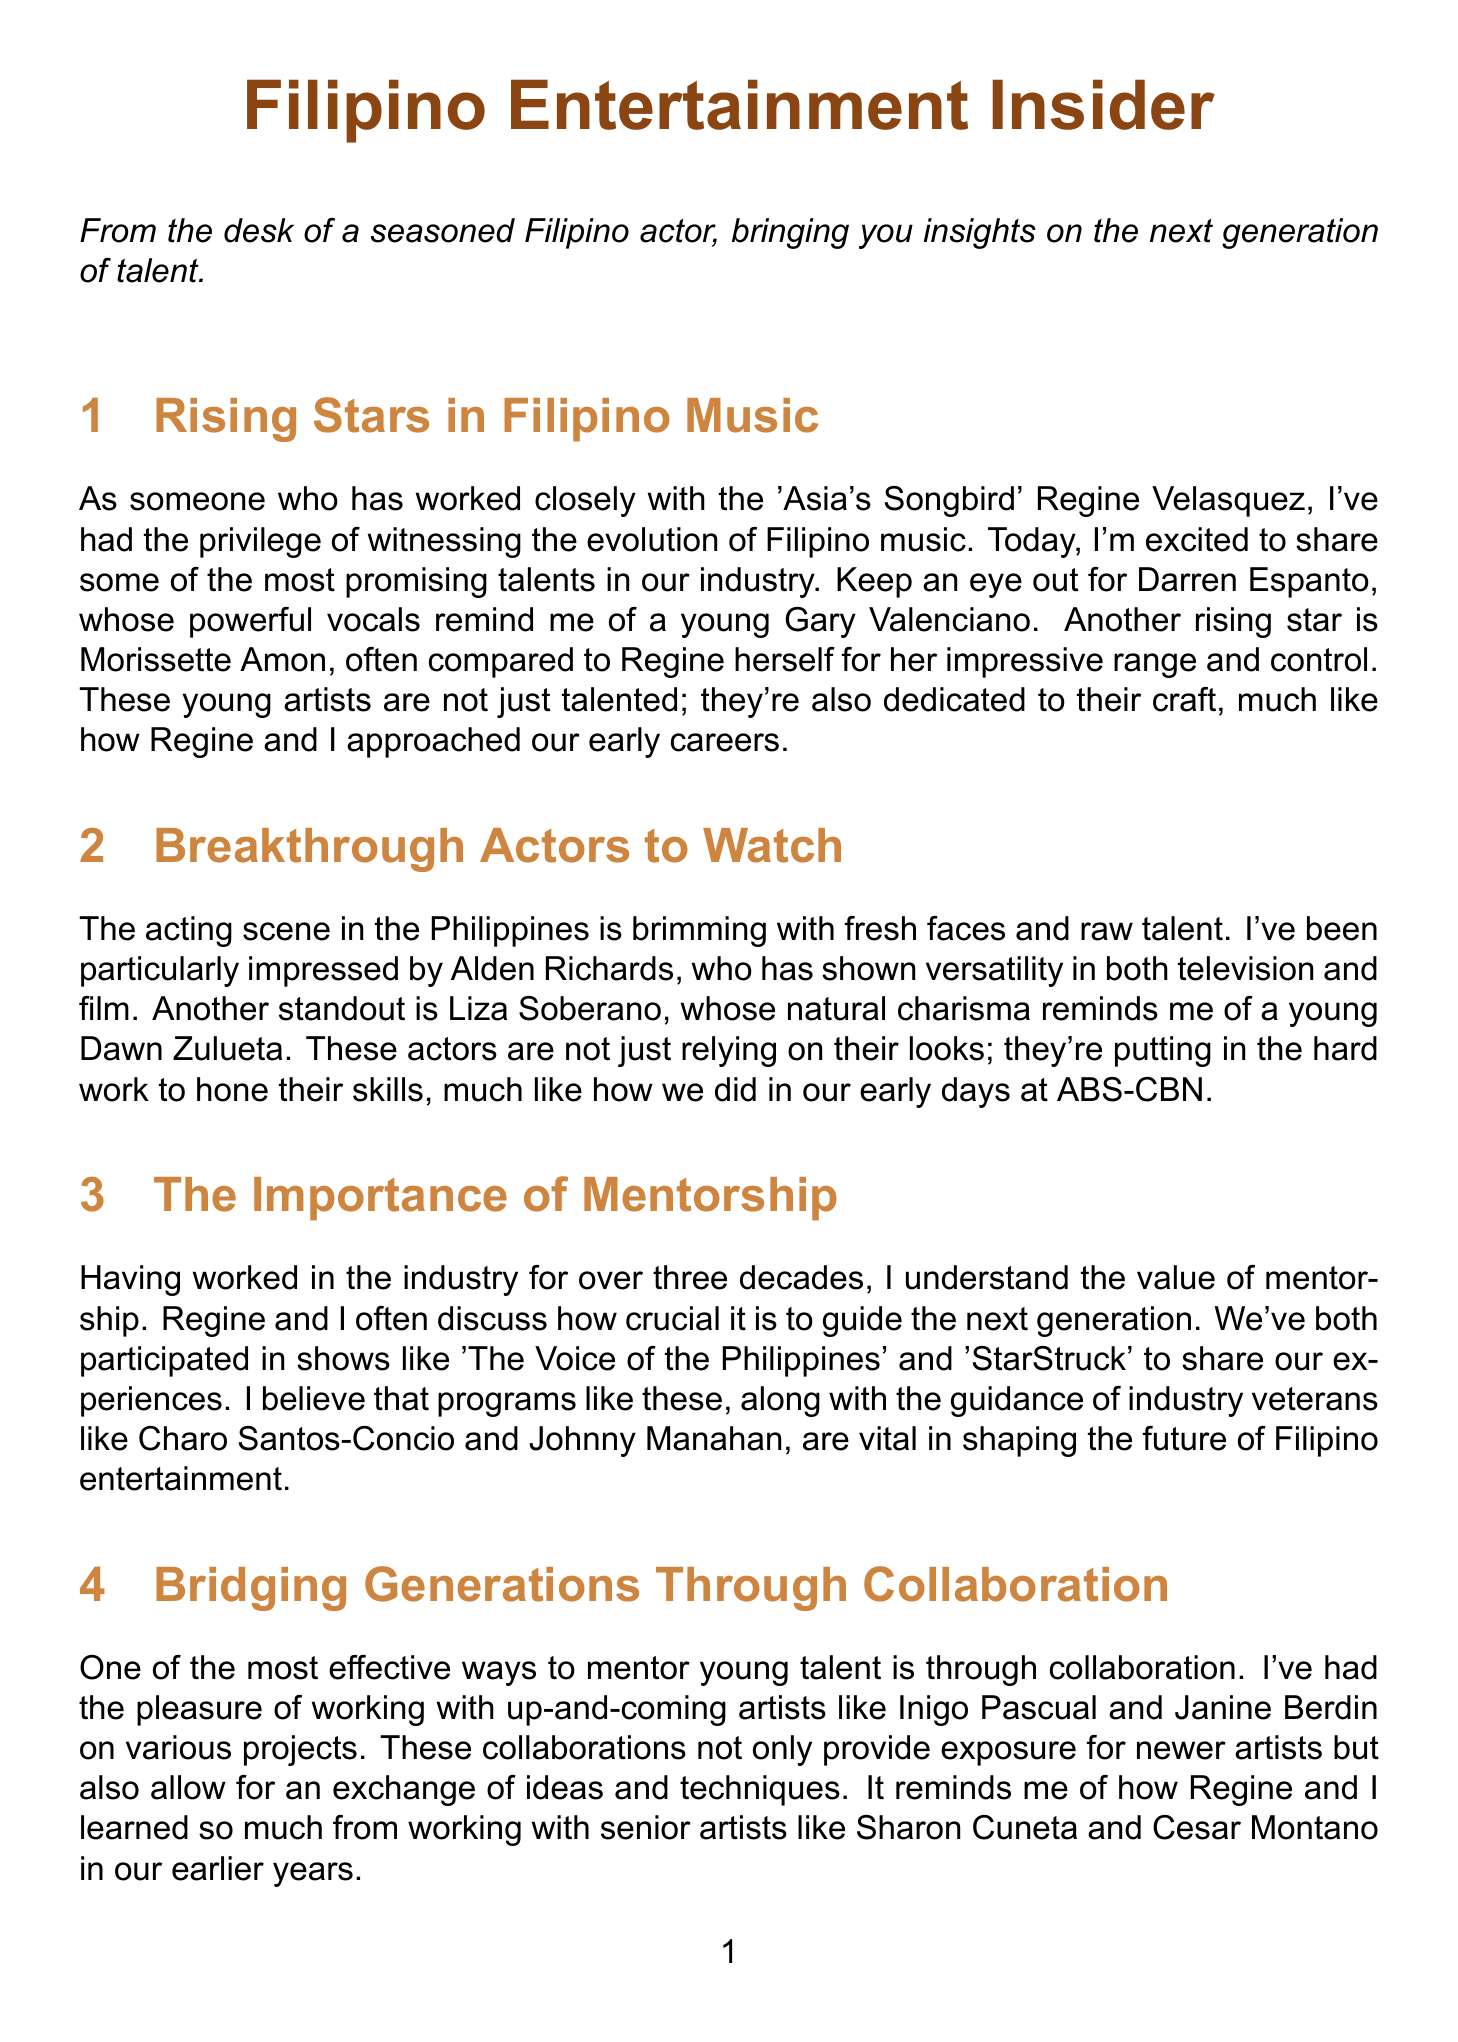What is the title of the newsletter? The title is provided at the beginning of the document and reflects the theme of the contents.
Answer: Filipino Entertainment Insider Who is often compared to Regine Velasquez for her impressive range? This question seeks to identify the young artist mentioned in the music section who is often likened to Regine.
Answer: Morissette Amon Which popular social media platforms are mentioned as breeding grounds for new talent? The document references specific platforms that are significant for talent discovery in the digital age.
Answer: TikTok and YouTube Who are the two breakthrough actors highlighted in the newsletter? This question looks for the names of the two actors mentioned in the section dedicated to acting talent.
Answer: Alden Richards and Liza Soberano What is emphasized as crucial for nurturing new talent? The document discusses a key aspect that is essential for mentoring the next generation in the entertainment industry.
Answer: Mentorship Which artists did the author collaborate with to provide exposure for newer talent? The question focuses on the specific newer artists mentioned in the collaboration section.
Answer: Inigo Pascual and Janine Berdin Who are the industry veterans mentioned in the importance of mentorship section? This question identifies recognized figures in the industry who play a pivotal role in mentoring young artists.
Answer: Charo Santos-Concio and Johnny Manahan What traditional elements do KZ Tandingan and Moira Dela Torre incorporate into their music? This question seeks to understand the type of elements these artists are noted for integrating in their work.
Answer: Traditional Filipino elements How many years of experience does the author have in the industry? This question asks for a specific numerical value that highlights the author's background.
Answer: Over three decades 